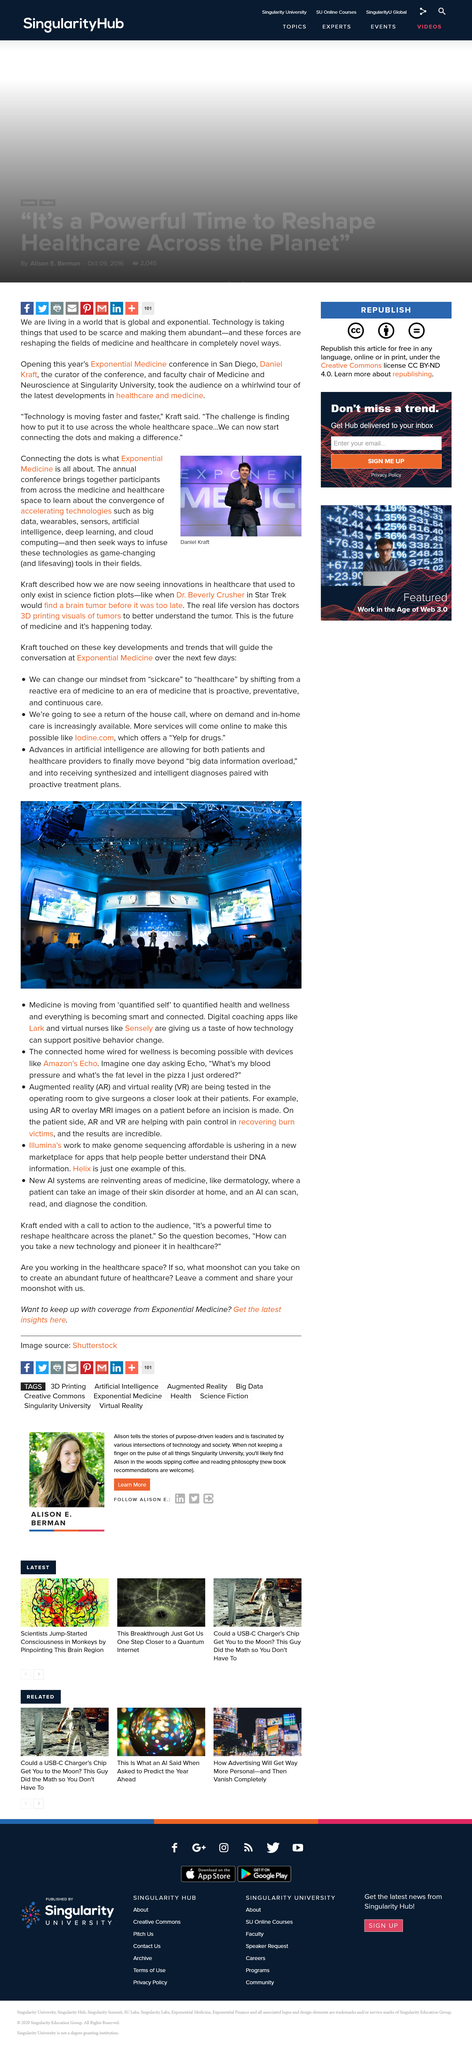Specify some key components in this picture. Lark is a digital coaching app that provides personalized guidance and support to users to help them achieve their goals and improve their overall well-being. Virtual reality is a term used to describe a computer-generated simulated environment that can be experienced through the senses, particularly sight and hearing. It is designed to create an immersive experience that can be similar to or more realistic than the real world. In other words, virtual reality is a technology that allows individuals to interact with a computer-generated environment in a way that simulates a real-life experience. It is my pleasure to inform the audience that the acronym AR stands for Augmented reality, which is a technology that enhances the real-world environment with computer-generated sensory inputs, such as sound, video, graphics, or GPS data, overlayed on the physical world. This technology has gained immense popularity in recent years and has the potential to revolutionize the way we interact with the world around us. The Exponential Medicine Conference took place in San Diedro. The conference was curated by Daniel Kraft. 